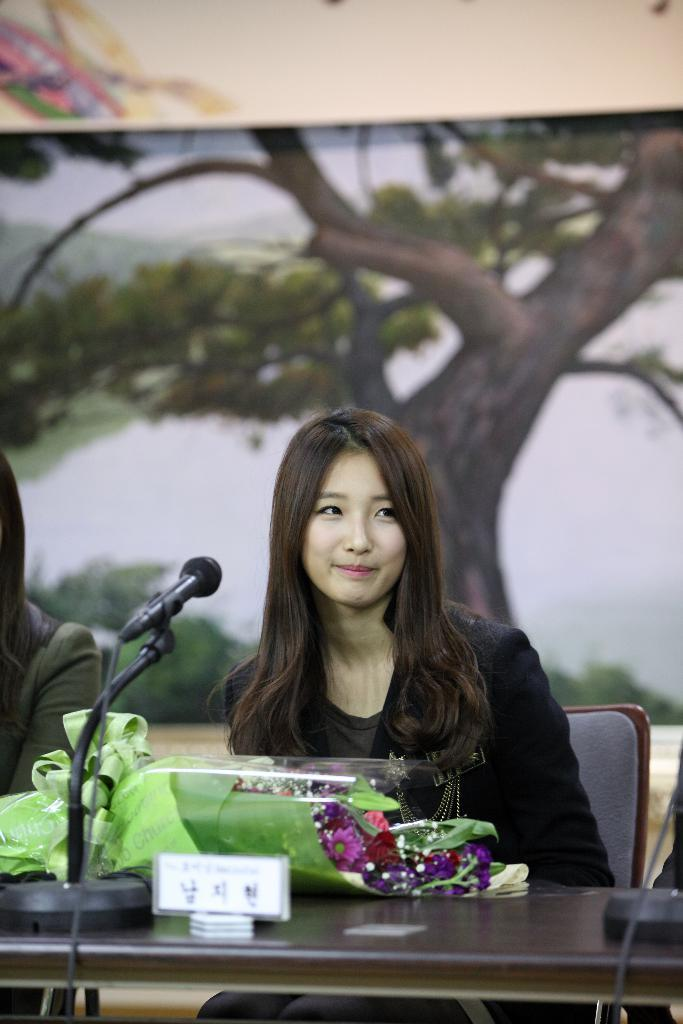What is the woman doing in the image? The woman is sitting on a chair in the image. What is located on the table in the image? There is a table in the image, and on it, there is a microphone and a bouquet with flowers. What can be seen in the background of the image? There is a poster with a tree on it in the background of the image. What is the title of the book the woman is reading in the image? There is no book present in the image, so it is not possible to determine the title. 